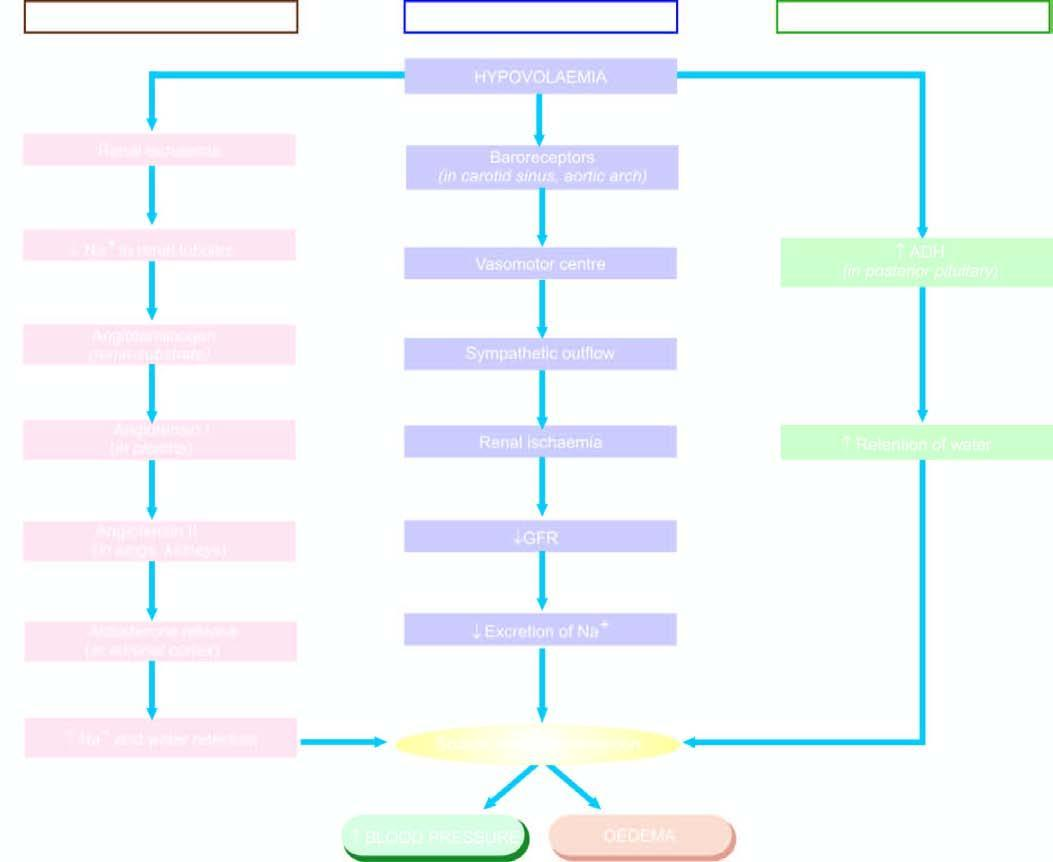how is mechanisms involved in oedema?
Answer the question using a single word or phrase. By sodium and water retention 